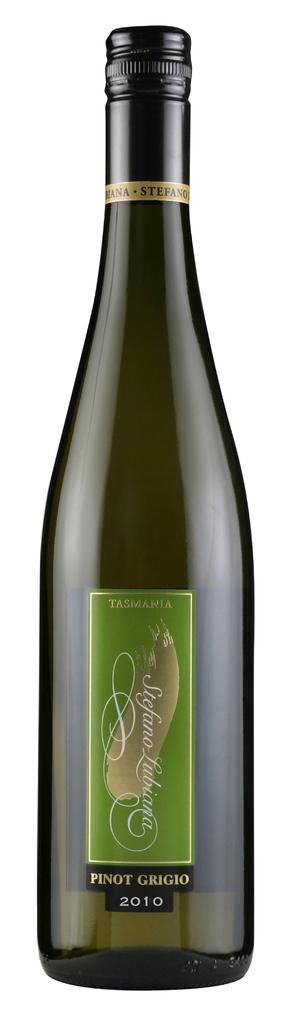Provide a one-sentence caption for the provided image. A bottle of Tasmania Pinot Grigio from 2010. 